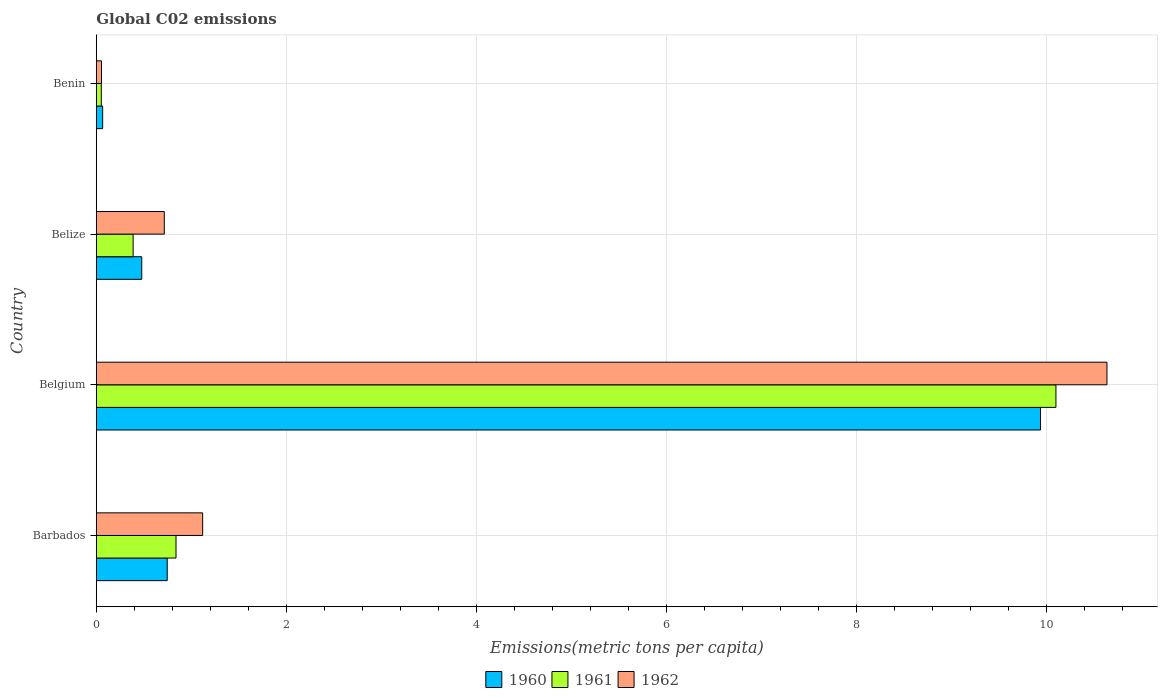How many different coloured bars are there?
Your answer should be compact. 3. How many groups of bars are there?
Provide a succinct answer. 4. Are the number of bars on each tick of the Y-axis equal?
Your response must be concise. Yes. How many bars are there on the 1st tick from the top?
Provide a short and direct response. 3. What is the label of the 2nd group of bars from the top?
Keep it short and to the point. Belize. In how many cases, is the number of bars for a given country not equal to the number of legend labels?
Ensure brevity in your answer.  0. What is the amount of CO2 emitted in in 1960 in Belize?
Provide a short and direct response. 0.48. Across all countries, what is the maximum amount of CO2 emitted in in 1960?
Make the answer very short. 9.94. Across all countries, what is the minimum amount of CO2 emitted in in 1962?
Offer a very short reply. 0.05. In which country was the amount of CO2 emitted in in 1962 maximum?
Make the answer very short. Belgium. In which country was the amount of CO2 emitted in in 1962 minimum?
Offer a very short reply. Benin. What is the total amount of CO2 emitted in in 1960 in the graph?
Provide a short and direct response. 11.23. What is the difference between the amount of CO2 emitted in in 1962 in Belize and that in Benin?
Your answer should be very brief. 0.66. What is the difference between the amount of CO2 emitted in in 1962 in Benin and the amount of CO2 emitted in in 1961 in Belgium?
Ensure brevity in your answer.  -10.05. What is the average amount of CO2 emitted in in 1961 per country?
Your response must be concise. 2.85. What is the difference between the amount of CO2 emitted in in 1961 and amount of CO2 emitted in in 1960 in Benin?
Your response must be concise. -0.01. In how many countries, is the amount of CO2 emitted in in 1960 greater than 2.4 metric tons per capita?
Keep it short and to the point. 1. What is the ratio of the amount of CO2 emitted in in 1961 in Barbados to that in Belgium?
Provide a short and direct response. 0.08. Is the amount of CO2 emitted in in 1962 in Belize less than that in Benin?
Provide a short and direct response. No. Is the difference between the amount of CO2 emitted in in 1961 in Belgium and Belize greater than the difference between the amount of CO2 emitted in in 1960 in Belgium and Belize?
Provide a succinct answer. Yes. What is the difference between the highest and the second highest amount of CO2 emitted in in 1960?
Provide a succinct answer. 9.2. What is the difference between the highest and the lowest amount of CO2 emitted in in 1960?
Give a very brief answer. 9.88. Is the sum of the amount of CO2 emitted in in 1962 in Barbados and Belize greater than the maximum amount of CO2 emitted in in 1960 across all countries?
Give a very brief answer. No. What does the 2nd bar from the bottom in Benin represents?
Your response must be concise. 1961. Are all the bars in the graph horizontal?
Offer a terse response. Yes. What is the difference between two consecutive major ticks on the X-axis?
Provide a short and direct response. 2. Are the values on the major ticks of X-axis written in scientific E-notation?
Give a very brief answer. No. Does the graph contain any zero values?
Your response must be concise. No. Where does the legend appear in the graph?
Give a very brief answer. Bottom center. How many legend labels are there?
Ensure brevity in your answer.  3. How are the legend labels stacked?
Keep it short and to the point. Horizontal. What is the title of the graph?
Your answer should be very brief. Global C02 emissions. Does "1974" appear as one of the legend labels in the graph?
Ensure brevity in your answer.  No. What is the label or title of the X-axis?
Give a very brief answer. Emissions(metric tons per capita). What is the Emissions(metric tons per capita) of 1960 in Barbados?
Give a very brief answer. 0.75. What is the Emissions(metric tons per capita) of 1961 in Barbados?
Give a very brief answer. 0.84. What is the Emissions(metric tons per capita) of 1962 in Barbados?
Make the answer very short. 1.12. What is the Emissions(metric tons per capita) of 1960 in Belgium?
Your answer should be compact. 9.94. What is the Emissions(metric tons per capita) of 1961 in Belgium?
Give a very brief answer. 10.1. What is the Emissions(metric tons per capita) in 1962 in Belgium?
Give a very brief answer. 10.64. What is the Emissions(metric tons per capita) in 1960 in Belize?
Your response must be concise. 0.48. What is the Emissions(metric tons per capita) in 1961 in Belize?
Ensure brevity in your answer.  0.39. What is the Emissions(metric tons per capita) of 1962 in Belize?
Make the answer very short. 0.72. What is the Emissions(metric tons per capita) of 1960 in Benin?
Keep it short and to the point. 0.07. What is the Emissions(metric tons per capita) in 1961 in Benin?
Your answer should be very brief. 0.05. What is the Emissions(metric tons per capita) in 1962 in Benin?
Make the answer very short. 0.05. Across all countries, what is the maximum Emissions(metric tons per capita) in 1960?
Your answer should be compact. 9.94. Across all countries, what is the maximum Emissions(metric tons per capita) of 1961?
Ensure brevity in your answer.  10.1. Across all countries, what is the maximum Emissions(metric tons per capita) in 1962?
Offer a very short reply. 10.64. Across all countries, what is the minimum Emissions(metric tons per capita) in 1960?
Make the answer very short. 0.07. Across all countries, what is the minimum Emissions(metric tons per capita) in 1961?
Provide a short and direct response. 0.05. Across all countries, what is the minimum Emissions(metric tons per capita) in 1962?
Provide a succinct answer. 0.05. What is the total Emissions(metric tons per capita) of 1960 in the graph?
Your answer should be compact. 11.23. What is the total Emissions(metric tons per capita) in 1961 in the graph?
Provide a succinct answer. 11.38. What is the total Emissions(metric tons per capita) of 1962 in the graph?
Your answer should be very brief. 12.53. What is the difference between the Emissions(metric tons per capita) of 1960 in Barbados and that in Belgium?
Your response must be concise. -9.2. What is the difference between the Emissions(metric tons per capita) of 1961 in Barbados and that in Belgium?
Give a very brief answer. -9.27. What is the difference between the Emissions(metric tons per capita) of 1962 in Barbados and that in Belgium?
Ensure brevity in your answer.  -9.52. What is the difference between the Emissions(metric tons per capita) in 1960 in Barbados and that in Belize?
Your answer should be compact. 0.27. What is the difference between the Emissions(metric tons per capita) in 1961 in Barbados and that in Belize?
Offer a terse response. 0.45. What is the difference between the Emissions(metric tons per capita) in 1962 in Barbados and that in Belize?
Offer a terse response. 0.4. What is the difference between the Emissions(metric tons per capita) in 1960 in Barbados and that in Benin?
Offer a very short reply. 0.68. What is the difference between the Emissions(metric tons per capita) of 1961 in Barbados and that in Benin?
Your answer should be compact. 0.79. What is the difference between the Emissions(metric tons per capita) in 1962 in Barbados and that in Benin?
Your response must be concise. 1.07. What is the difference between the Emissions(metric tons per capita) of 1960 in Belgium and that in Belize?
Your response must be concise. 9.46. What is the difference between the Emissions(metric tons per capita) of 1961 in Belgium and that in Belize?
Ensure brevity in your answer.  9.72. What is the difference between the Emissions(metric tons per capita) of 1962 in Belgium and that in Belize?
Make the answer very short. 9.93. What is the difference between the Emissions(metric tons per capita) in 1960 in Belgium and that in Benin?
Provide a short and direct response. 9.88. What is the difference between the Emissions(metric tons per capita) of 1961 in Belgium and that in Benin?
Offer a terse response. 10.05. What is the difference between the Emissions(metric tons per capita) of 1962 in Belgium and that in Benin?
Offer a terse response. 10.59. What is the difference between the Emissions(metric tons per capita) of 1960 in Belize and that in Benin?
Offer a terse response. 0.41. What is the difference between the Emissions(metric tons per capita) in 1961 in Belize and that in Benin?
Your answer should be compact. 0.34. What is the difference between the Emissions(metric tons per capita) in 1962 in Belize and that in Benin?
Your answer should be compact. 0.66. What is the difference between the Emissions(metric tons per capita) of 1960 in Barbados and the Emissions(metric tons per capita) of 1961 in Belgium?
Make the answer very short. -9.36. What is the difference between the Emissions(metric tons per capita) in 1960 in Barbados and the Emissions(metric tons per capita) in 1962 in Belgium?
Make the answer very short. -9.89. What is the difference between the Emissions(metric tons per capita) in 1961 in Barbados and the Emissions(metric tons per capita) in 1962 in Belgium?
Keep it short and to the point. -9.8. What is the difference between the Emissions(metric tons per capita) in 1960 in Barbados and the Emissions(metric tons per capita) in 1961 in Belize?
Your response must be concise. 0.36. What is the difference between the Emissions(metric tons per capita) in 1960 in Barbados and the Emissions(metric tons per capita) in 1962 in Belize?
Keep it short and to the point. 0.03. What is the difference between the Emissions(metric tons per capita) in 1961 in Barbados and the Emissions(metric tons per capita) in 1962 in Belize?
Make the answer very short. 0.12. What is the difference between the Emissions(metric tons per capita) of 1960 in Barbados and the Emissions(metric tons per capita) of 1961 in Benin?
Offer a terse response. 0.69. What is the difference between the Emissions(metric tons per capita) in 1960 in Barbados and the Emissions(metric tons per capita) in 1962 in Benin?
Your answer should be compact. 0.69. What is the difference between the Emissions(metric tons per capita) of 1961 in Barbados and the Emissions(metric tons per capita) of 1962 in Benin?
Provide a succinct answer. 0.78. What is the difference between the Emissions(metric tons per capita) in 1960 in Belgium and the Emissions(metric tons per capita) in 1961 in Belize?
Provide a short and direct response. 9.55. What is the difference between the Emissions(metric tons per capita) in 1960 in Belgium and the Emissions(metric tons per capita) in 1962 in Belize?
Provide a short and direct response. 9.23. What is the difference between the Emissions(metric tons per capita) of 1961 in Belgium and the Emissions(metric tons per capita) of 1962 in Belize?
Provide a short and direct response. 9.39. What is the difference between the Emissions(metric tons per capita) of 1960 in Belgium and the Emissions(metric tons per capita) of 1961 in Benin?
Your response must be concise. 9.89. What is the difference between the Emissions(metric tons per capita) of 1960 in Belgium and the Emissions(metric tons per capita) of 1962 in Benin?
Ensure brevity in your answer.  9.89. What is the difference between the Emissions(metric tons per capita) of 1961 in Belgium and the Emissions(metric tons per capita) of 1962 in Benin?
Keep it short and to the point. 10.05. What is the difference between the Emissions(metric tons per capita) of 1960 in Belize and the Emissions(metric tons per capita) of 1961 in Benin?
Offer a very short reply. 0.43. What is the difference between the Emissions(metric tons per capita) of 1960 in Belize and the Emissions(metric tons per capita) of 1962 in Benin?
Make the answer very short. 0.42. What is the difference between the Emissions(metric tons per capita) in 1961 in Belize and the Emissions(metric tons per capita) in 1962 in Benin?
Keep it short and to the point. 0.33. What is the average Emissions(metric tons per capita) of 1960 per country?
Your answer should be compact. 2.81. What is the average Emissions(metric tons per capita) in 1961 per country?
Ensure brevity in your answer.  2.85. What is the average Emissions(metric tons per capita) in 1962 per country?
Your answer should be compact. 3.13. What is the difference between the Emissions(metric tons per capita) of 1960 and Emissions(metric tons per capita) of 1961 in Barbados?
Offer a very short reply. -0.09. What is the difference between the Emissions(metric tons per capita) in 1960 and Emissions(metric tons per capita) in 1962 in Barbados?
Keep it short and to the point. -0.37. What is the difference between the Emissions(metric tons per capita) in 1961 and Emissions(metric tons per capita) in 1962 in Barbados?
Ensure brevity in your answer.  -0.28. What is the difference between the Emissions(metric tons per capita) of 1960 and Emissions(metric tons per capita) of 1961 in Belgium?
Offer a very short reply. -0.16. What is the difference between the Emissions(metric tons per capita) of 1960 and Emissions(metric tons per capita) of 1962 in Belgium?
Your answer should be compact. -0.7. What is the difference between the Emissions(metric tons per capita) in 1961 and Emissions(metric tons per capita) in 1962 in Belgium?
Your answer should be compact. -0.54. What is the difference between the Emissions(metric tons per capita) of 1960 and Emissions(metric tons per capita) of 1961 in Belize?
Provide a short and direct response. 0.09. What is the difference between the Emissions(metric tons per capita) of 1960 and Emissions(metric tons per capita) of 1962 in Belize?
Make the answer very short. -0.24. What is the difference between the Emissions(metric tons per capita) of 1961 and Emissions(metric tons per capita) of 1962 in Belize?
Provide a succinct answer. -0.33. What is the difference between the Emissions(metric tons per capita) of 1960 and Emissions(metric tons per capita) of 1961 in Benin?
Give a very brief answer. 0.01. What is the difference between the Emissions(metric tons per capita) in 1960 and Emissions(metric tons per capita) in 1962 in Benin?
Ensure brevity in your answer.  0.01. What is the difference between the Emissions(metric tons per capita) in 1961 and Emissions(metric tons per capita) in 1962 in Benin?
Keep it short and to the point. -0. What is the ratio of the Emissions(metric tons per capita) in 1960 in Barbados to that in Belgium?
Provide a short and direct response. 0.08. What is the ratio of the Emissions(metric tons per capita) in 1961 in Barbados to that in Belgium?
Offer a very short reply. 0.08. What is the ratio of the Emissions(metric tons per capita) in 1962 in Barbados to that in Belgium?
Your response must be concise. 0.11. What is the ratio of the Emissions(metric tons per capita) in 1960 in Barbados to that in Belize?
Your answer should be very brief. 1.56. What is the ratio of the Emissions(metric tons per capita) in 1961 in Barbados to that in Belize?
Offer a very short reply. 2.17. What is the ratio of the Emissions(metric tons per capita) of 1962 in Barbados to that in Belize?
Give a very brief answer. 1.56. What is the ratio of the Emissions(metric tons per capita) of 1960 in Barbados to that in Benin?
Your response must be concise. 11.25. What is the ratio of the Emissions(metric tons per capita) in 1961 in Barbados to that in Benin?
Provide a succinct answer. 16.12. What is the ratio of the Emissions(metric tons per capita) of 1962 in Barbados to that in Benin?
Keep it short and to the point. 20.65. What is the ratio of the Emissions(metric tons per capita) in 1960 in Belgium to that in Belize?
Offer a terse response. 20.8. What is the ratio of the Emissions(metric tons per capita) of 1961 in Belgium to that in Belize?
Make the answer very short. 26.09. What is the ratio of the Emissions(metric tons per capita) of 1962 in Belgium to that in Belize?
Provide a succinct answer. 14.87. What is the ratio of the Emissions(metric tons per capita) of 1960 in Belgium to that in Benin?
Ensure brevity in your answer.  149.83. What is the ratio of the Emissions(metric tons per capita) of 1961 in Belgium to that in Benin?
Your answer should be compact. 194.13. What is the ratio of the Emissions(metric tons per capita) in 1962 in Belgium to that in Benin?
Your response must be concise. 196.33. What is the ratio of the Emissions(metric tons per capita) in 1960 in Belize to that in Benin?
Provide a succinct answer. 7.2. What is the ratio of the Emissions(metric tons per capita) of 1961 in Belize to that in Benin?
Keep it short and to the point. 7.44. What is the ratio of the Emissions(metric tons per capita) of 1962 in Belize to that in Benin?
Give a very brief answer. 13.2. What is the difference between the highest and the second highest Emissions(metric tons per capita) in 1960?
Your answer should be compact. 9.2. What is the difference between the highest and the second highest Emissions(metric tons per capita) of 1961?
Provide a short and direct response. 9.27. What is the difference between the highest and the second highest Emissions(metric tons per capita) of 1962?
Make the answer very short. 9.52. What is the difference between the highest and the lowest Emissions(metric tons per capita) in 1960?
Provide a short and direct response. 9.88. What is the difference between the highest and the lowest Emissions(metric tons per capita) in 1961?
Keep it short and to the point. 10.05. What is the difference between the highest and the lowest Emissions(metric tons per capita) in 1962?
Your response must be concise. 10.59. 